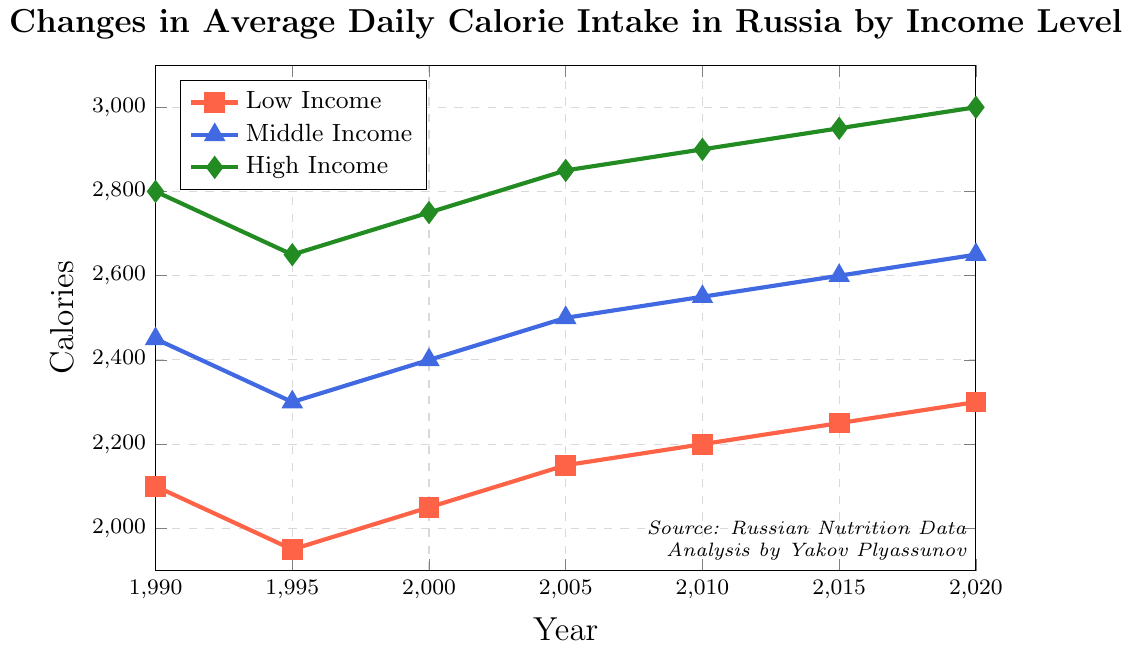What's the difference in average daily calorie intake between High Income and Low Income groups in 1990? In 1990, the High Income group's calorie intake is 2800, and the Low Income group's calorie intake is 2100. The difference is 2800 - 2100.
Answer: 700 Which income group had the lowest average daily calorie intake in 1995? According to the data, the Low Income group had an average daily calorie intake of 1950, the Middle Income group had 2300, and the High Income group had 2650. The Low Income group had the lowest intake.
Answer: Low Income How did the calorie intake for the Middle Income group change from 1995 to 2005? In 1995, the Middle Income group's calorie intake was 2300. By 2005, it increased to 2500. The change can be quantified as 2500 - 2300.
Answer: 200 Which year saw the highest average daily calorie intake for the Low Income group? Reviewing the data, the Low Income group's calorie intake progressively increases from 1990 to 2020, reaching its highest in 2020 with an intake of 2300 calories.
Answer: 2020 Compare the calorie intake trends between the Middle Income and High Income groups from 2000 to 2020. From 2000 to 2020, the Middle Income group's intake increased from 2400 to 2650, and the High Income group's intake increased from 2750 to 3000. Both groups show an upward trend.
Answer: Both increased What is the average calorie intake of the High Income group between 1990 and 2020? The average is calculated by summing the data points (2800 + 2650 + 2750 + 2850 + 2900 + 2950 + 3000) and dividing by the number of years, which is 7. Total is 19900, so the average is 19900 / 7.
Answer: 2842.86 In which year did the Low Income group experience the lowest average daily calorie intake? According to the data, the Low Income group's lowest intake was in 1995 with 1950 calories.
Answer: 1995 What's the visual trend of the calorie intake for all income groups from 1990 to 2020? Observing the figure, all income groups show a general upward trend from 1990 to 2020, despite some fluctuations.
Answer: Upward trend Compare the calorie intake in 2010 for all income groups. Which group had the highest intake? In 2010, the Low Income group's intake was 2200, Middle Income group's was 2550, and High Income group's was 2900. The High Income group had the highest intake.
Answer: High Income 